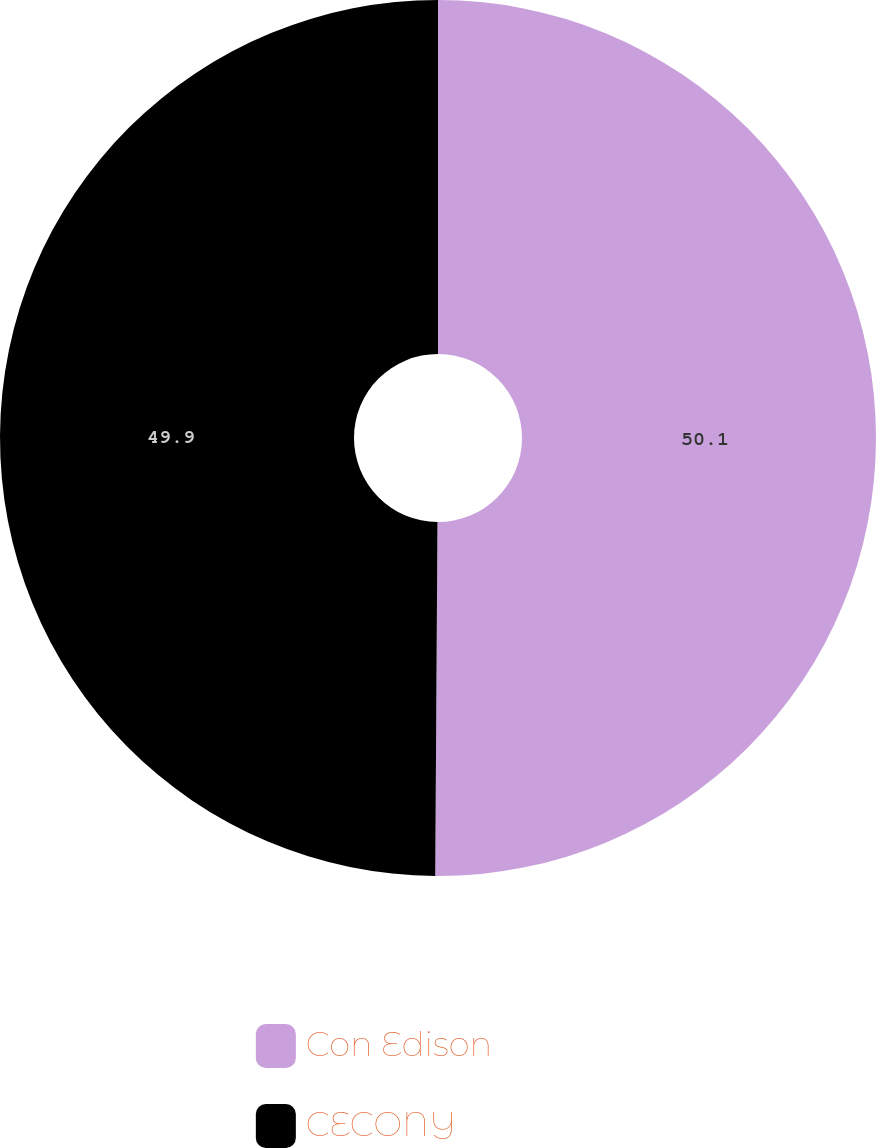<chart> <loc_0><loc_0><loc_500><loc_500><pie_chart><fcel>Con Edison<fcel>CECONY<nl><fcel>50.1%<fcel>49.9%<nl></chart> 